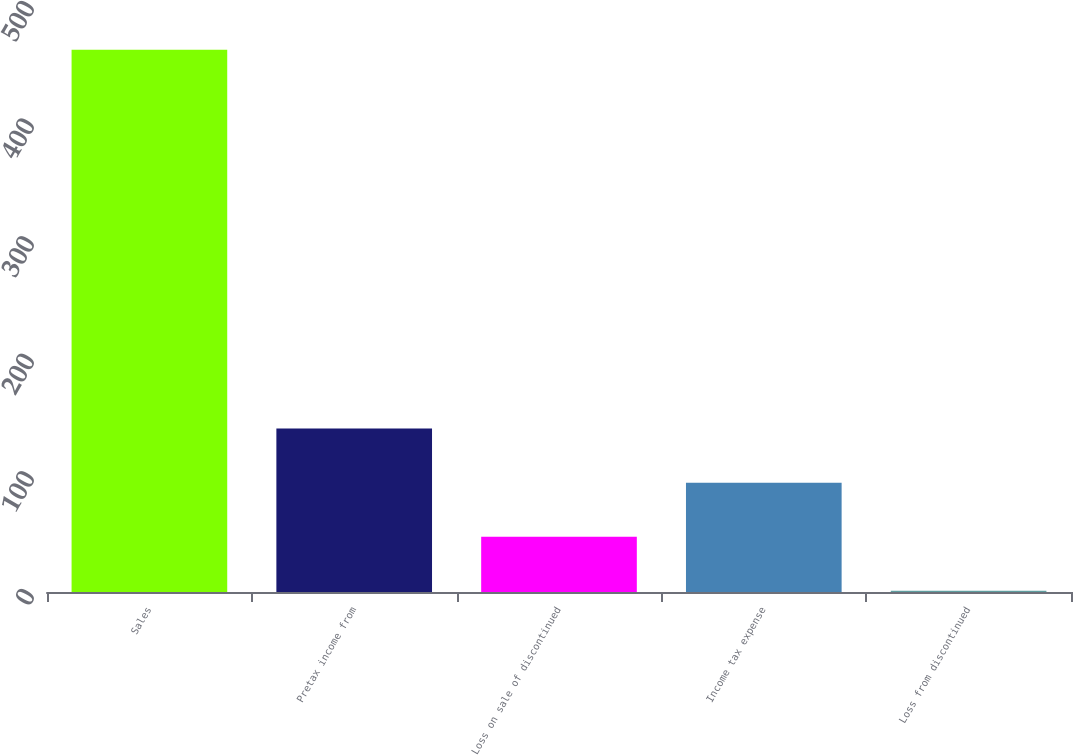Convert chart. <chart><loc_0><loc_0><loc_500><loc_500><bar_chart><fcel>Sales<fcel>Pretax income from<fcel>Loss on sale of discontinued<fcel>Income tax expense<fcel>Loss from discontinued<nl><fcel>461<fcel>139<fcel>47<fcel>93<fcel>1<nl></chart> 